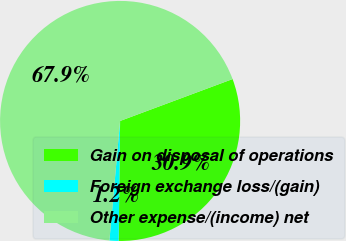Convert chart. <chart><loc_0><loc_0><loc_500><loc_500><pie_chart><fcel>Gain on disposal of operations<fcel>Foreign exchange loss/(gain)<fcel>Other expense/(income) net<nl><fcel>30.86%<fcel>1.23%<fcel>67.9%<nl></chart> 